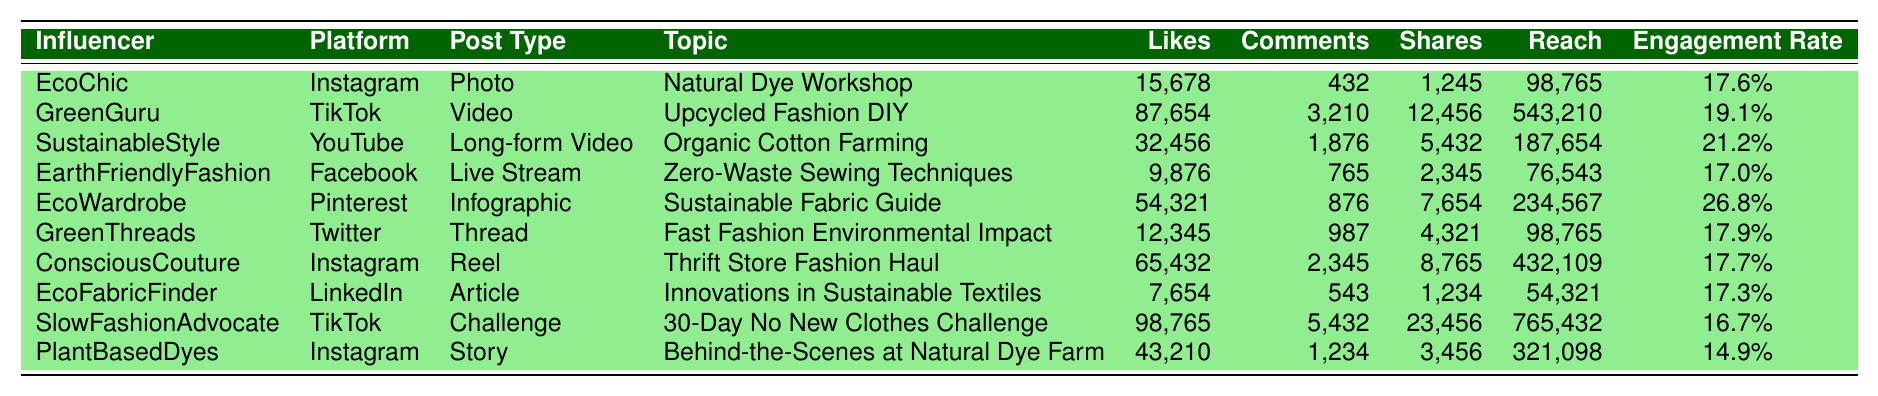What is the post with the highest number of likes? In the table, the likes for each post are listed. Scanning through the likes, "GreenGuru" has the highest number with 87,654 likes.
Answer: 87,654 Which platform has the lowest engagement rate? The engagement rates for each post are shown in the last column. By comparing these rates, "PlantBasedDyes" has the lowest engagement rate of 14.9%.
Answer: 14.9% What is the total number of shares for Instagram posts? The shares for each Instagram post are added: "EcoChic" (1,245), "ConsciousCouture" (8,765), and "PlantBasedDyes" (3,456). The total is 1,245 + 8,765 + 3,456 = 13,466 shares.
Answer: 13,466 Is there a post on TikTok with an engagement rate above 18%? The engagement rates for TikTok posts are checked: "GreenGuru" (19.1%) is above 18%, while "SlowFashionAdvocate" (16.7%) is not. So yes, there is a post with an engagement rate above 18%.
Answer: Yes What is the average number of comments across all posts? The number of comments for each post is: 432, 3,210, 1,876, 765, 876, 987, 2,345, 543, 5,432, and 1,234. Adding these gives 16,055 total comments. Divided by 10 (for the 10 posts), the average is 16,055 / 10 = 1,605.5.
Answer: 1,605.5 Which post type received the most shares? The shares for each post type are compared: Photo (1,245), Video (12,456), Long-form Video (5,432), Live Stream (2,345), Infographic (7,654), Thread (4,321), Reel (8,765), Article (1,234), Challenge (23,456), and Story (3,456). The "Challenge" post by "SlowFashionAdvocate" received the most shares with 23,456.
Answer: 23,456 What is the reach of the post with the most comments? Looking at the comments, "SlowFashionAdvocate" has the highest with 5,432 comments. Checking the reach for this post, it is 765,432.
Answer: 765,432 How many more likes did the "EcoWardrobe" post receive compared to "EarthFriendlyFashion"? The likes of "EcoWardrobe" are 54,321 and "EarthFriendlyFashion" has 9,876 likes. The difference is 54,321 - 9,876 = 44,445 more likes.
Answer: 44,445 Which topic had the highest engagement rate and what is that rate? By reviewing the engagement rates, "EcoWardrobe" has the highest engagement rate at 26.8%.
Answer: 26.8% Did any influencer use Instagram to post a story? The table shows that "PlantBasedDyes" created a story on Instagram. Therefore, yes, an influencer used Instagram for a story.
Answer: Yes What is the total reach for all posts on 'YouTube'? The reach for the YouTube post "SustainableStyle" is 187,654. As it's the only post on YouTube, the total reach is also 187,654.
Answer: 187,654 